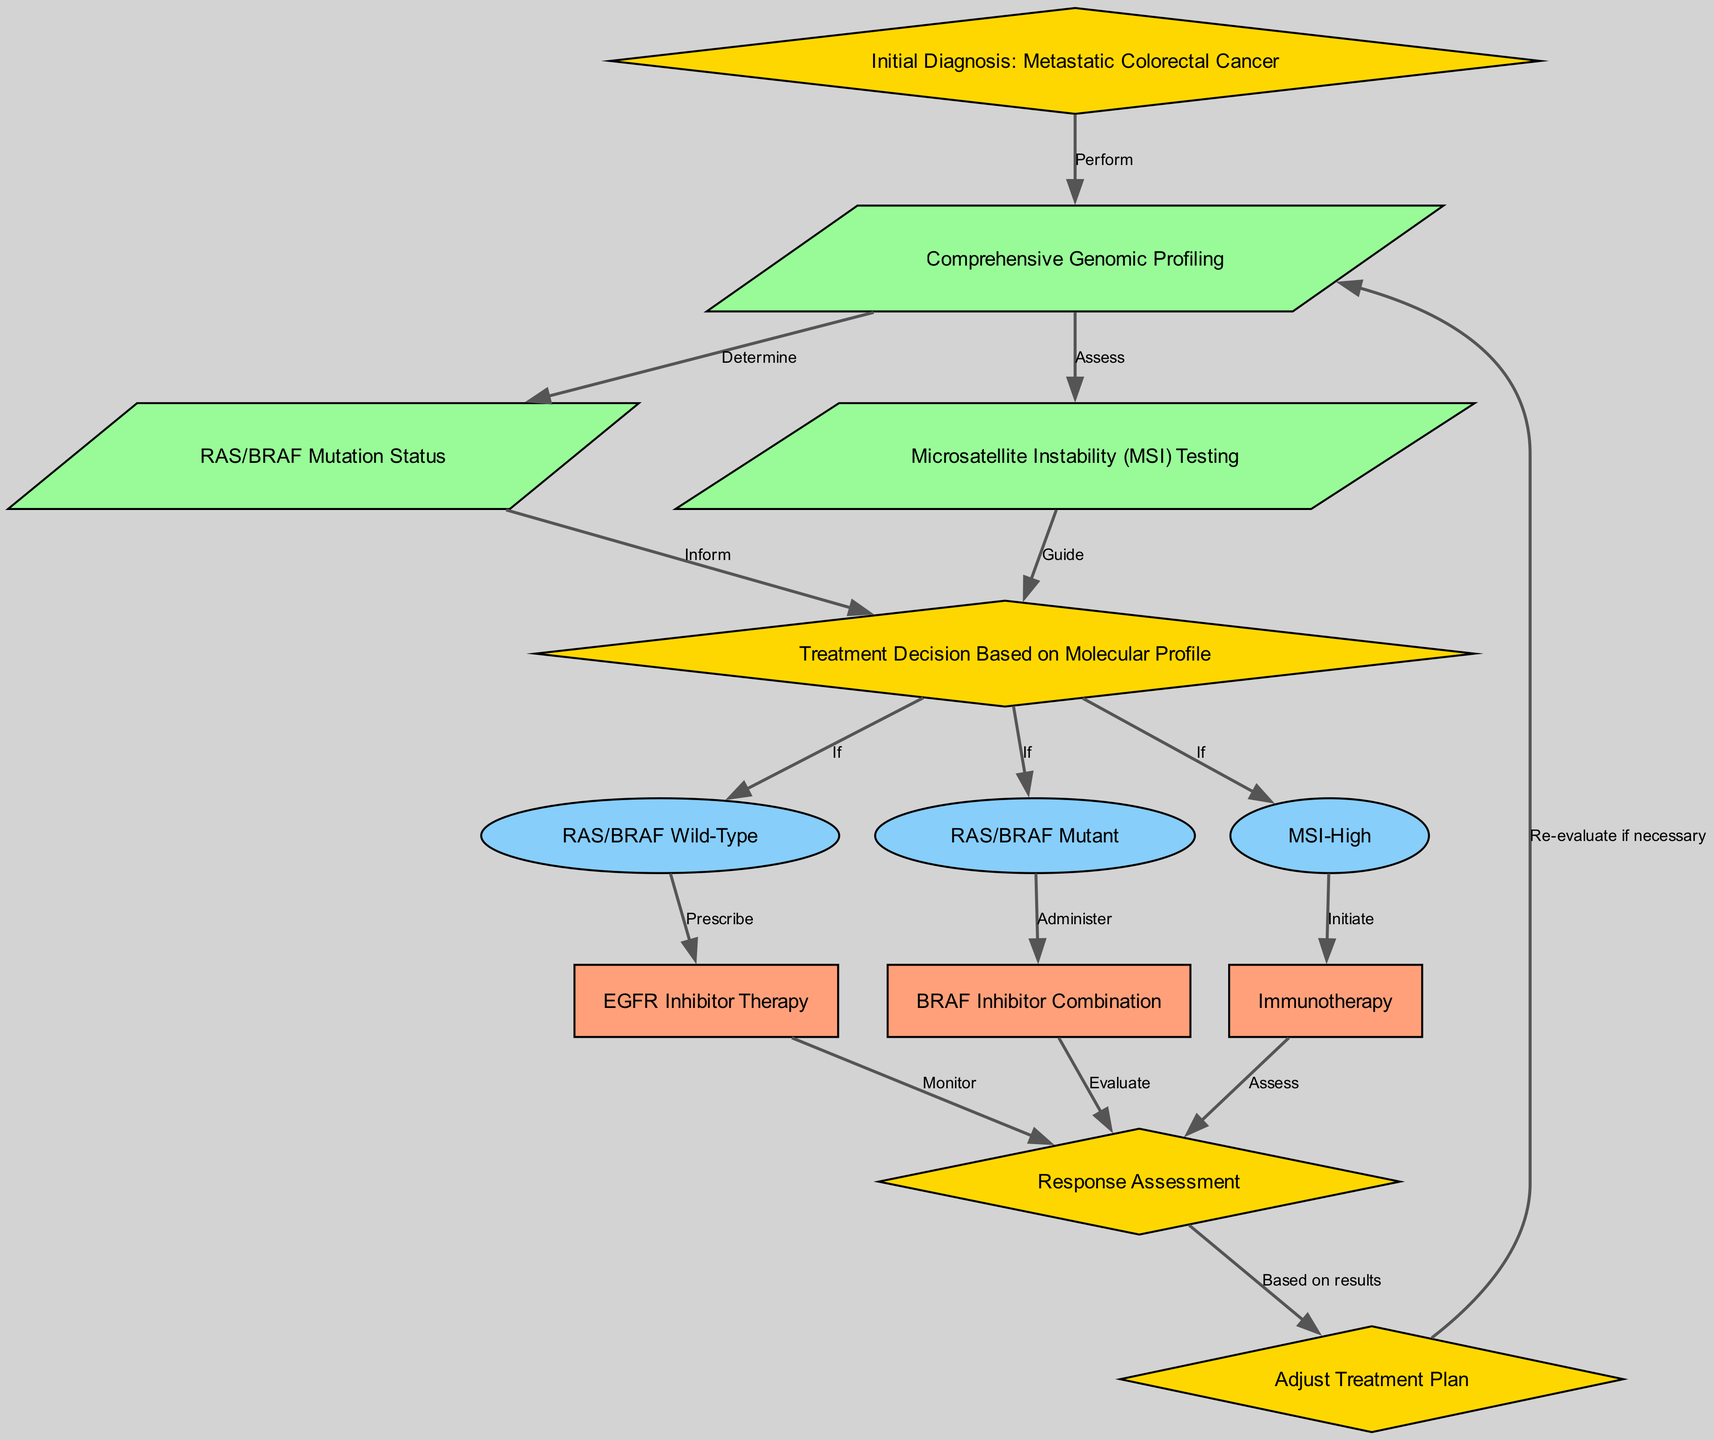What is the first step in the pathway? The first step, identified by node "1", is "Initial Diagnosis: Metastatic Colorectal Cancer". This information is directly provided in the diagram as the starting point of the clinical pathway.
Answer: Initial Diagnosis: Metastatic Colorectal Cancer How many treatment options are listed based on the molecular profile? The diagram outlines three treatment options that emerge from node "5": the options "EGFR Inhibitor Therapy", "BRAF Inhibitor Combination", and "Immunotherapy", which correspond to nodes "9", "10", and "11" respectively. Thus, there are three treatment options total.
Answer: Three What follows after comprehensive genomic profiling? After "Comprehensive Genomic Profiling", the next steps involve determining "RAS/BRAF Mutation Status" and assessing "Microsatellite Instability (MSI) Testing", as shown by the edges connecting node "2" to nodes "3" and "4".
Answer: RAS/BRAF Mutation Status and Microsatellite Instability Testing What action is taken if the RAS/BRAF status is wild-type? If the status is wild-type, the pathway indicates that "EGFR Inhibitor Therapy" is prescribed, as derived from the connection between node "6" and node "9", showing the outcome for wild-type cases.
Answer: Prescribe EGFR Inhibitor Therapy Describe the treatment for MSI-High patients according to the pathway. For patients with "MSI-High", the pathway specifies to "Initiate Immunotherapy" as indicated by the connection from node "8" to node "11". This is a direct link showing the corresponding treatment for this group.
Answer: Initiate Immunotherapy What should be done after response assessment? After assessing the response, the pathway suggests adjusting the treatment plan "Based on results", which is derived from node "12" leading to node "13". This shows that treatment plans may need to be re-evaluated based on how patients respond.
Answer: Adjust Treatment Plan Which status leads to administering a BRAF inhibitor combination? The pathway indicates that if the status shows "RAS/BRAF Mutant" (node "7"), the action taken is to "Administer BRAF Inhibitor Combination" as detailed by the connection between node "7" and node "10".
Answer: Administer BRAF Inhibitor Combination What guides the treatment decision in the pathway? The treatment decision is guided by both the "RAS/BRAF Mutation Status" and "Microsatellite Instability (MSI) Testing" results, as these nodes lead to the final treatment decision node "5". Both tests inform the direct course of action for patient treatment.
Answer: RAS/BRAF Mutation Status and Microsatellite Instability Testing 